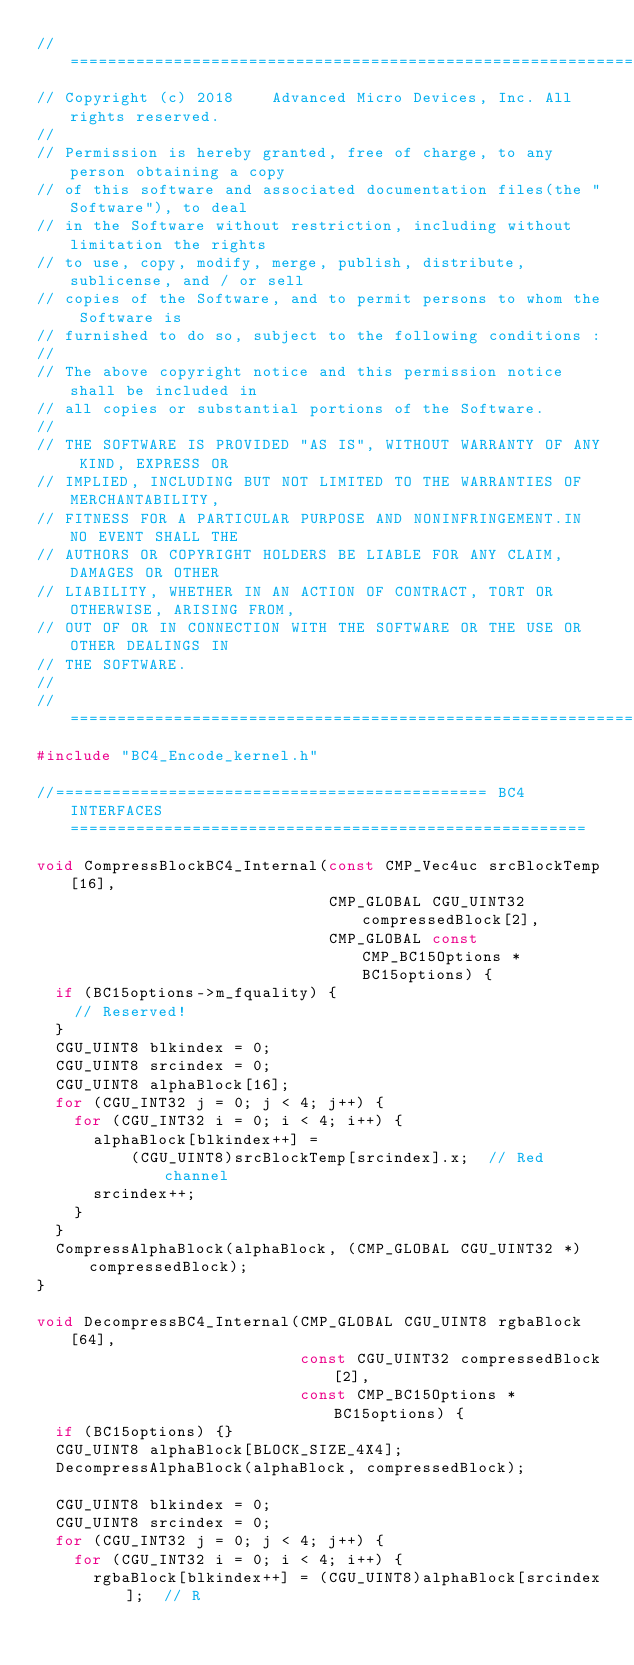<code> <loc_0><loc_0><loc_500><loc_500><_C++_>//=====================================================================
// Copyright (c) 2018    Advanced Micro Devices, Inc. All rights reserved.
//
// Permission is hereby granted, free of charge, to any person obtaining a copy
// of this software and associated documentation files(the "Software"), to deal
// in the Software without restriction, including without limitation the rights
// to use, copy, modify, merge, publish, distribute, sublicense, and / or sell
// copies of the Software, and to permit persons to whom the Software is
// furnished to do so, subject to the following conditions :
//
// The above copyright notice and this permission notice shall be included in
// all copies or substantial portions of the Software.
//
// THE SOFTWARE IS PROVIDED "AS IS", WITHOUT WARRANTY OF ANY KIND, EXPRESS OR
// IMPLIED, INCLUDING BUT NOT LIMITED TO THE WARRANTIES OF MERCHANTABILITY,
// FITNESS FOR A PARTICULAR PURPOSE AND NONINFRINGEMENT.IN NO EVENT SHALL THE
// AUTHORS OR COPYRIGHT HOLDERS BE LIABLE FOR ANY CLAIM, DAMAGES OR OTHER
// LIABILITY, WHETHER IN AN ACTION OF CONTRACT, TORT OR OTHERWISE, ARISING FROM,
// OUT OF OR IN CONNECTION WITH THE SOFTWARE OR THE USE OR OTHER DEALINGS IN
// THE SOFTWARE.
//
//=====================================================================
#include "BC4_Encode_kernel.h"

//============================================== BC4 INTERFACES =======================================================

void CompressBlockBC4_Internal(const CMP_Vec4uc srcBlockTemp[16],
                               CMP_GLOBAL CGU_UINT32 compressedBlock[2],
                               CMP_GLOBAL const CMP_BC15Options *BC15options) {
  if (BC15options->m_fquality) {
    // Reserved!
  }
  CGU_UINT8 blkindex = 0;
  CGU_UINT8 srcindex = 0;
  CGU_UINT8 alphaBlock[16];
  for (CGU_INT32 j = 0; j < 4; j++) {
    for (CGU_INT32 i = 0; i < 4; i++) {
      alphaBlock[blkindex++] =
          (CGU_UINT8)srcBlockTemp[srcindex].x;  // Red channel
      srcindex++;
    }
  }
  CompressAlphaBlock(alphaBlock, (CMP_GLOBAL CGU_UINT32 *)compressedBlock);
}

void DecompressBC4_Internal(CMP_GLOBAL CGU_UINT8 rgbaBlock[64],
                            const CGU_UINT32 compressedBlock[2],
                            const CMP_BC15Options *BC15options) {
  if (BC15options) {}
  CGU_UINT8 alphaBlock[BLOCK_SIZE_4X4];
  DecompressAlphaBlock(alphaBlock, compressedBlock);

  CGU_UINT8 blkindex = 0;
  CGU_UINT8 srcindex = 0;
  for (CGU_INT32 j = 0; j < 4; j++) {
    for (CGU_INT32 i = 0; i < 4; i++) {
      rgbaBlock[blkindex++] = (CGU_UINT8)alphaBlock[srcindex];  // R</code> 